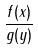Convert formula to latex. <formula><loc_0><loc_0><loc_500><loc_500>\frac { f ( x ) } { g ( y ) }</formula> 